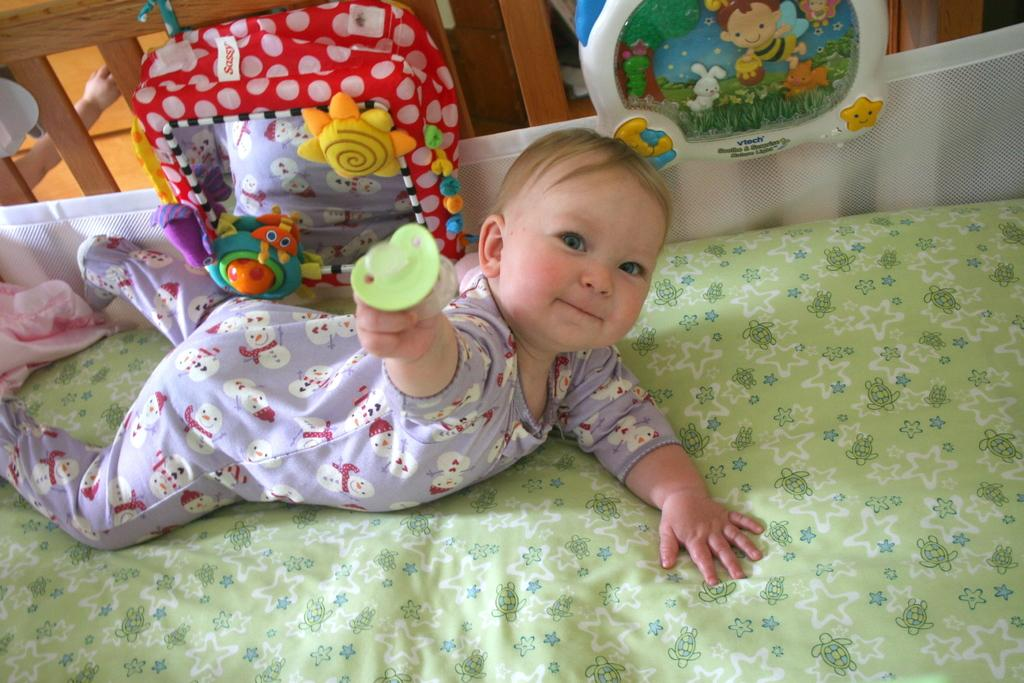What is the main subject of the image? There is a baby in the image. Where is the baby located? The baby is lying on a bed. What can be seen in the background of the image? There are toys in the background of the image. What type of impulse does the committee have in the image? There is no committee or impulse present in the image; it features a baby lying on a bed with toys in the background. 